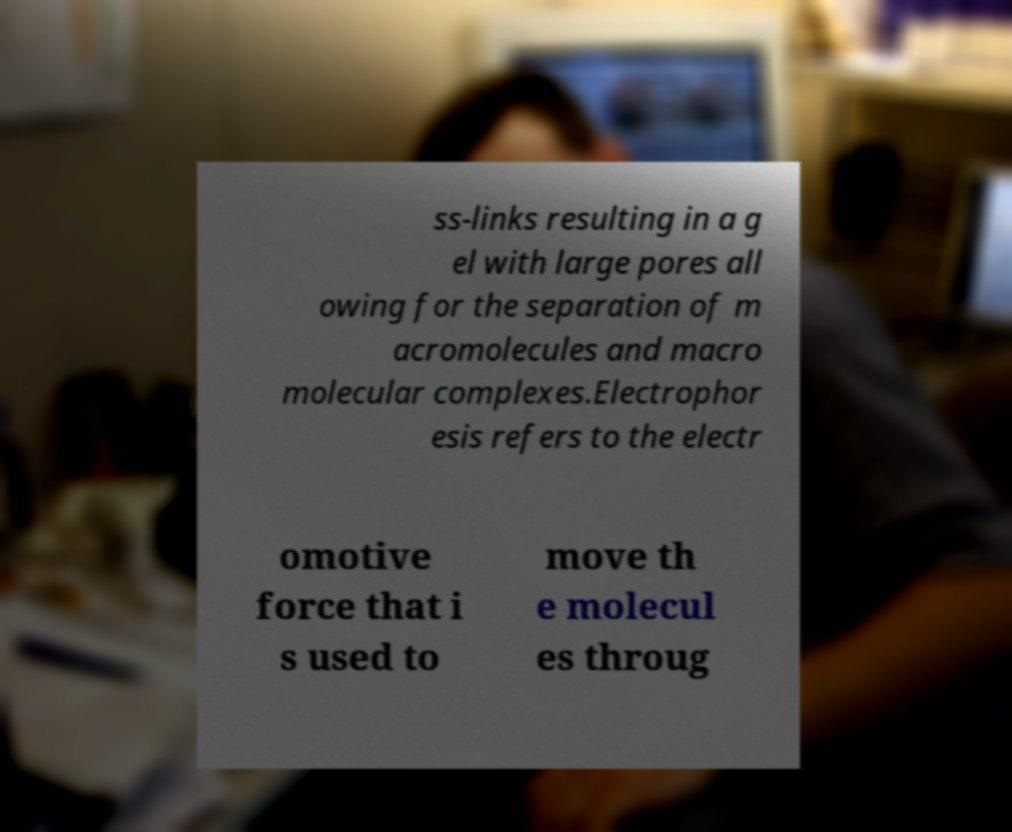For documentation purposes, I need the text within this image transcribed. Could you provide that? ss-links resulting in a g el with large pores all owing for the separation of m acromolecules and macro molecular complexes.Electrophor esis refers to the electr omotive force that i s used to move th e molecul es throug 